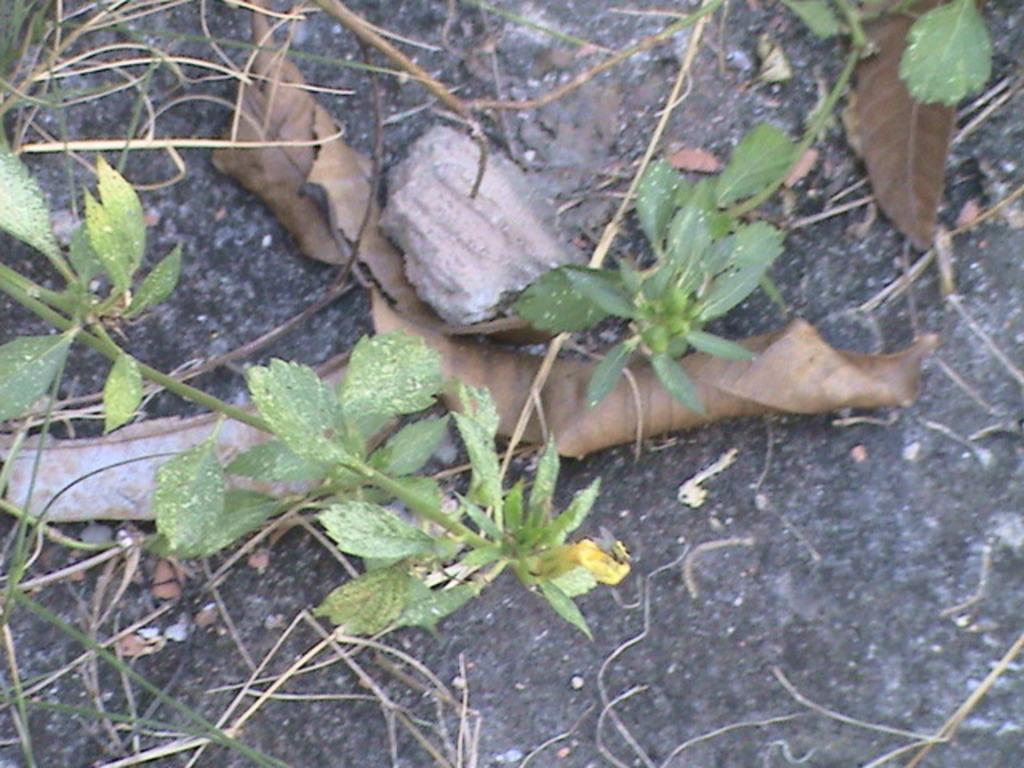In one or two sentences, can you explain what this image depicts? In the center of this picture we can see the green leaves and stems of the plants and we can see the dry leaves and some other objects are lying on the surface of an object. 